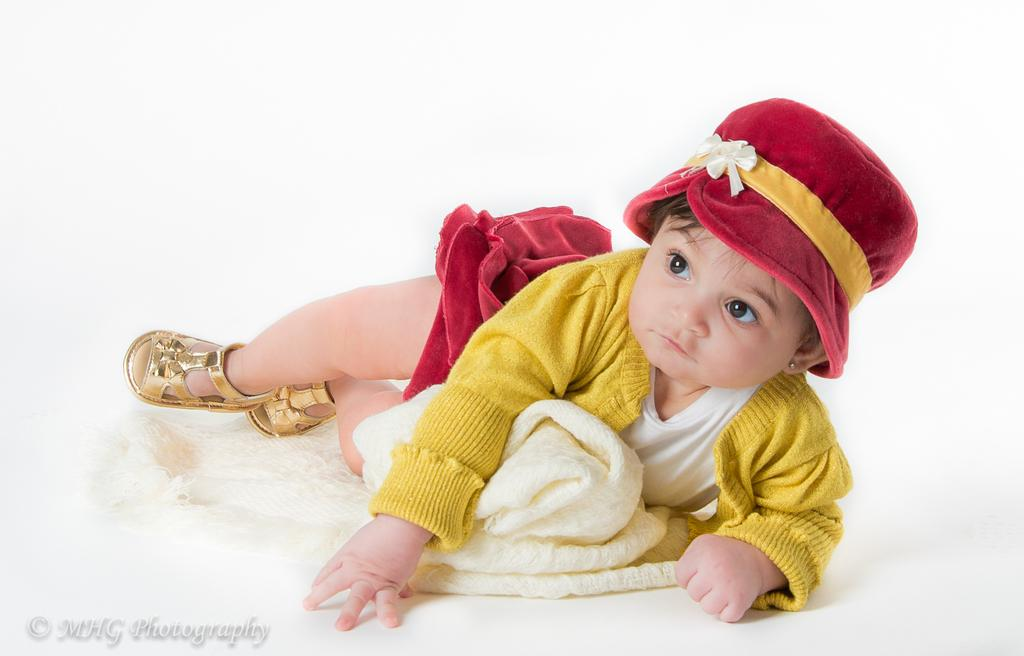What is the main subject of the image? The main subject of the image is a kid. What is the kid doing in the image? The kid is lying down. What is the kid wearing on their head? The kid is wearing a hat. What is the chance of the kid winning a soap-making contest in the image? There is no indication of a soap-making contest or any contest in the image, so it cannot be determined from the image. 